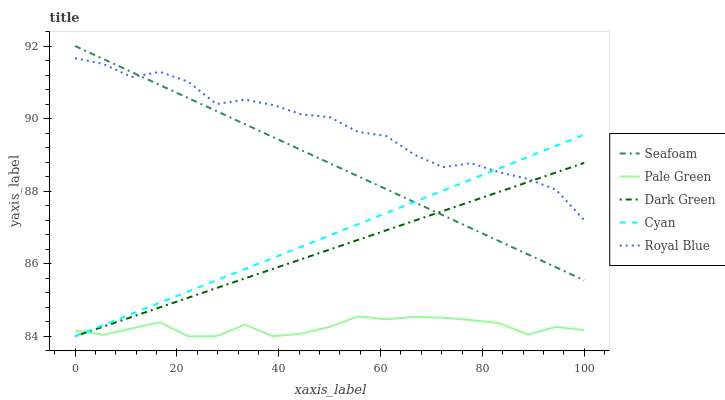Does Pale Green have the minimum area under the curve?
Answer yes or no. Yes. Does Royal Blue have the maximum area under the curve?
Answer yes or no. Yes. Does Seafoam have the minimum area under the curve?
Answer yes or no. No. Does Seafoam have the maximum area under the curve?
Answer yes or no. No. Is Dark Green the smoothest?
Answer yes or no. Yes. Is Royal Blue the roughest?
Answer yes or no. Yes. Is Pale Green the smoothest?
Answer yes or no. No. Is Pale Green the roughest?
Answer yes or no. No. Does Cyan have the lowest value?
Answer yes or no. Yes. Does Seafoam have the lowest value?
Answer yes or no. No. Does Seafoam have the highest value?
Answer yes or no. Yes. Does Pale Green have the highest value?
Answer yes or no. No. Is Pale Green less than Royal Blue?
Answer yes or no. Yes. Is Royal Blue greater than Pale Green?
Answer yes or no. Yes. Does Dark Green intersect Pale Green?
Answer yes or no. Yes. Is Dark Green less than Pale Green?
Answer yes or no. No. Is Dark Green greater than Pale Green?
Answer yes or no. No. Does Pale Green intersect Royal Blue?
Answer yes or no. No. 